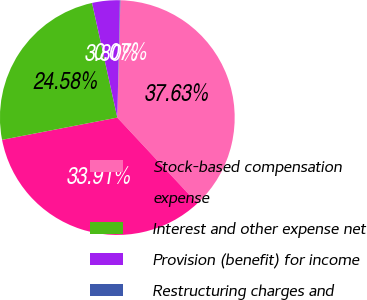Convert chart. <chart><loc_0><loc_0><loc_500><loc_500><pie_chart><fcel>Stock-based compensation<fcel>expense<fcel>Interest and other expense net<fcel>Provision (benefit) for income<fcel>Restructuring charges and<nl><fcel>37.63%<fcel>33.91%<fcel>24.58%<fcel>3.8%<fcel>0.07%<nl></chart> 